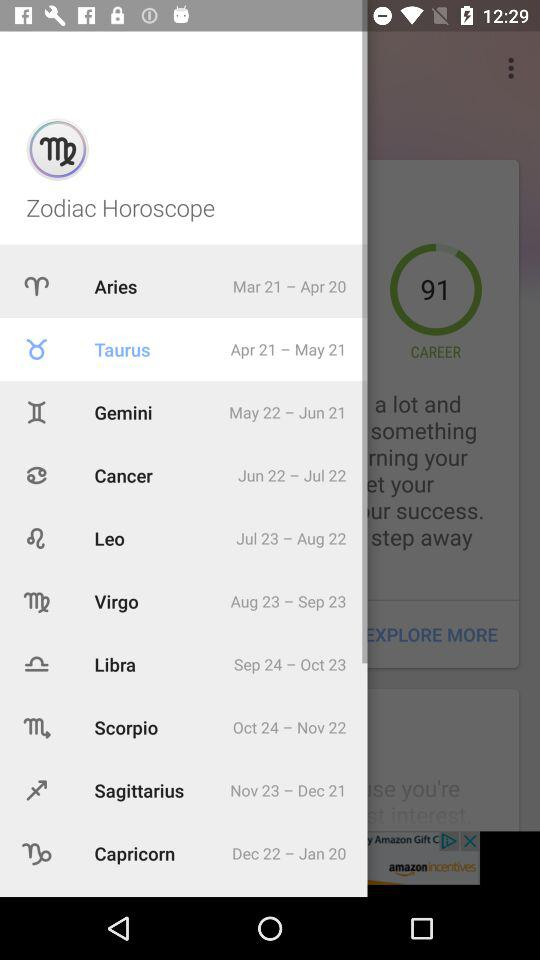What is the "Cancer" time period? The "Cancer" time period is from June 22 to July 22. 